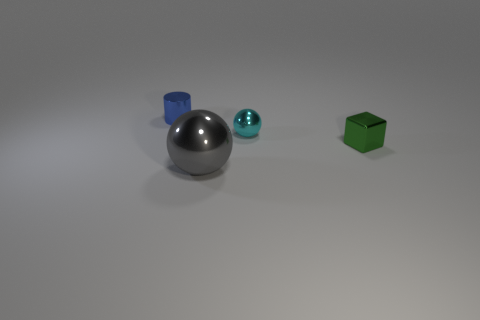Can you tell me what materials the objects might be made of? Based on the image, the objects appear to have different materials. The sphere in the center has a reflective surface that suggests it could be made of metal. The cyan-colored object also has a metallic finish, whereas the green cube looks like it could be made of a matte plastic or painted wood due to its less reflective surface. 